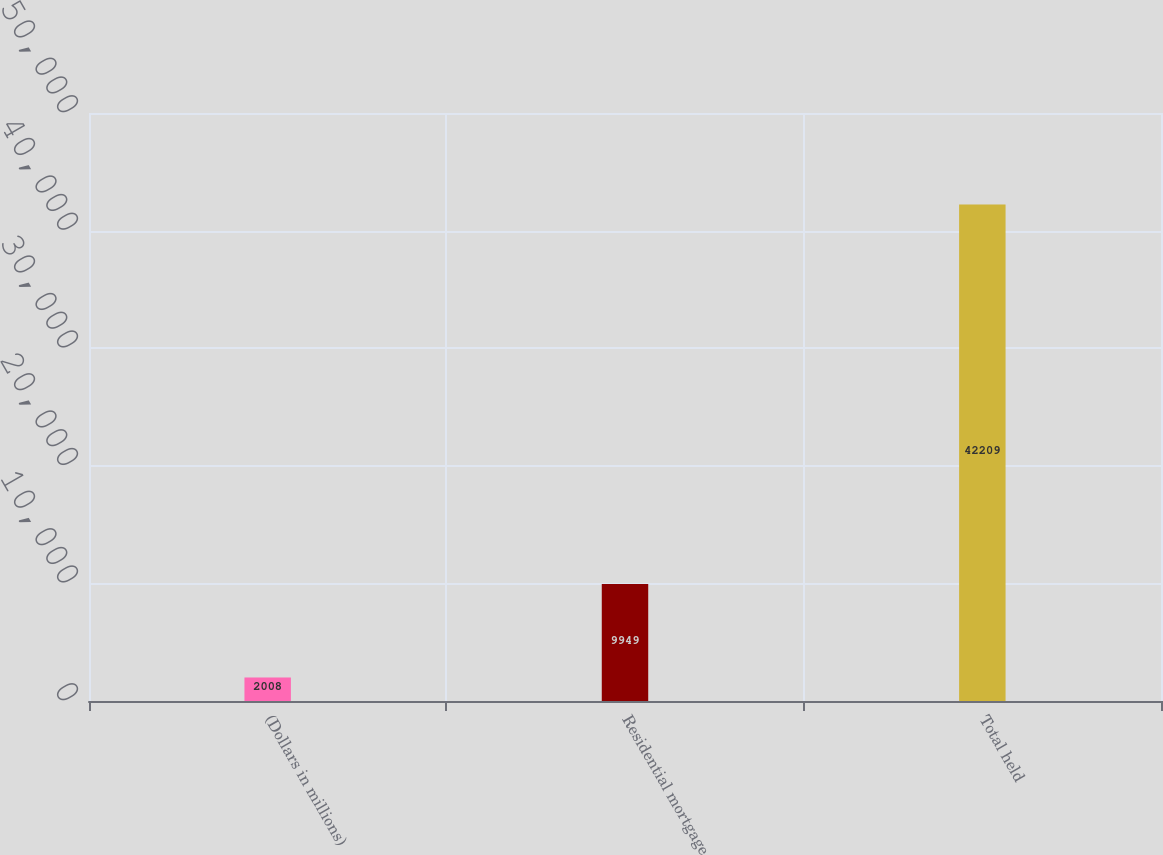<chart> <loc_0><loc_0><loc_500><loc_500><bar_chart><fcel>(Dollars in millions)<fcel>Residential mortgage<fcel>Total held<nl><fcel>2008<fcel>9949<fcel>42209<nl></chart> 